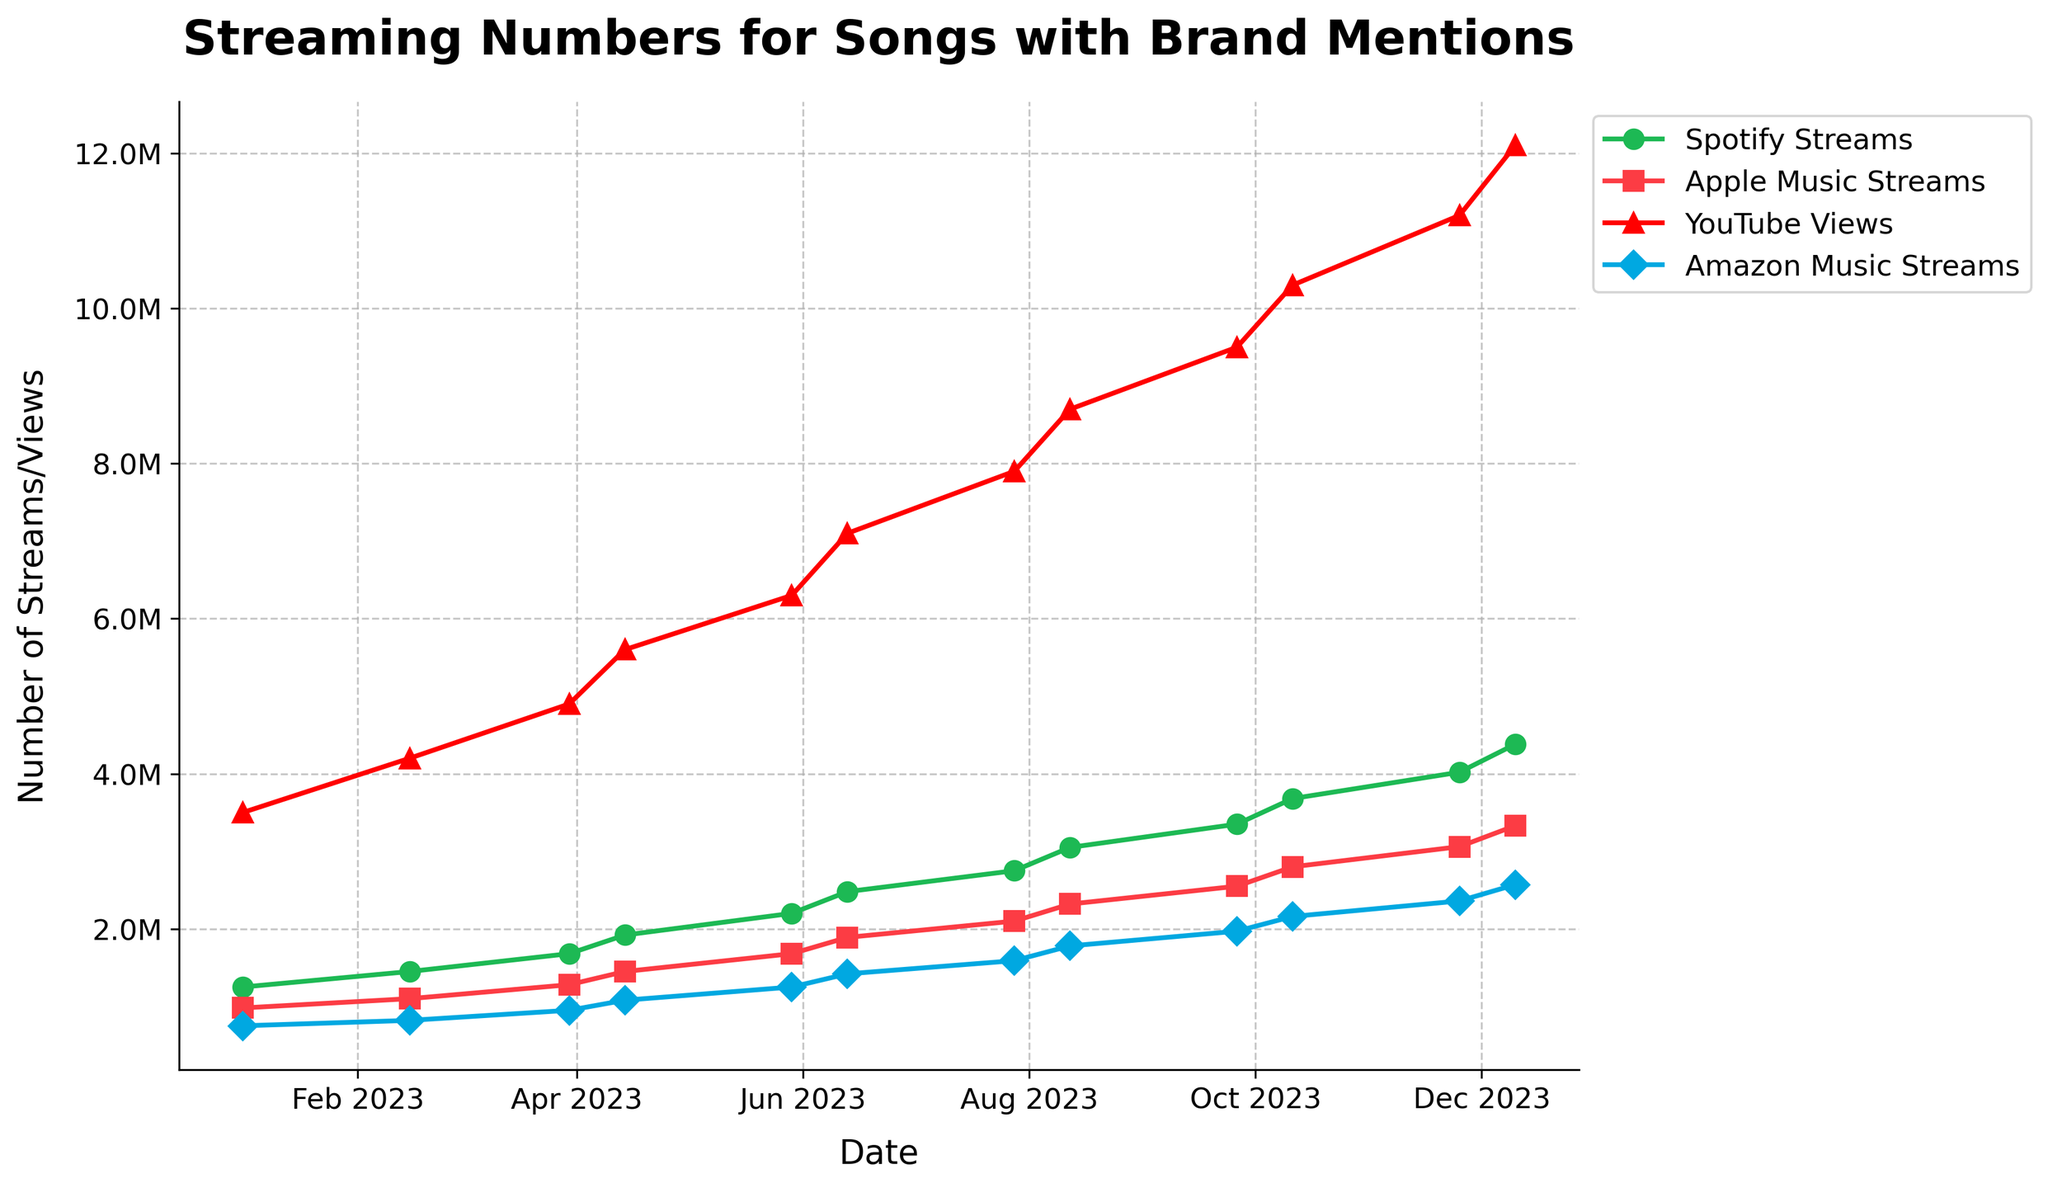How do the number of YouTube Views compare to Spotify Streams on December 10, 2023? YouTube Views are 12.1 million on December 10, 2023, while Spotify Streams are 4.38 million on the same date. By comparing these figures, YouTube Views are substantially higher than Spotify Streams.
Answer: YouTube Views are higher What is the difference between Apple Music Streams on June 13, 2023, and September 26, 2023? Apple Music Streams on June 13, 2023, were 1.89 million, and on September 26, 2023, they were 2.55 million. The difference is calculated as 2.55 million - 1.89 million = 0.66 million.
Answer: 0.66 million Which platform shows the highest growth from January 1, 2023, to December 10, 2023? To determine the highest growth, we calculate the increase for each platform from January 1, 2023, to December 10, 2023:
- Spotify: 4.38 million - 1.25 million = 3.13 million
- Apple Music: 3.33 million - 0.98 million = 2.35 million
- YouTube: 12.1 million - 3.5 million = 8.6 million
- Amazon Music: 2.57 million - 0.75 million = 1.82 million
YouTube shows the highest growth of 8.6 million.
Answer: YouTube Which platform had the least number of streams/views on March 30, 2023? On March 30, 2023, the data is as follows:
- Spotify Streams: 1.68 million 
- Apple Music Streams: 1.28 million 
- YouTube Views: 4.9 million 
- Amazon Music Streams: 0.95 million
Amazon Music Streams had the least number of streams/views with 0.95 million.
Answer: Amazon Music What was the average number of Spotify Streams across all the given dates? First, sum up all the Spotify Streams and then divide by the number of data points:
(1.25 + 1.45 + 1.68 + 1.92 + 2.20 + 2.48 + 2.75 + 3.05 + 3.35 + 3.68 + 4.02 + 4.38) million / 12 = 2.72 million.
Answer: 2.72 million On what date did Amazon Music Streams first exceed 1 million? The data shows that on May 29, 2023, Amazon Music Streams reached 1.25 million, which is the first time it exceeded 1 million.
Answer: May 29, 2023 How much did the number of YouTube Views increase from June 13, 2023, to December 10, 2023? YouTube Views on June 13, 2023, were 7.1 million, and on December 10, 2023, they were 12.1 million. To find the increase, subtract the initial value from the final value: 12.1 million - 7.1 million = 5 million.
Answer: 5 million What are the total streams/views for all platforms combined on November 25, 2023? To find the total, we sum the streaming numbers for all platforms on November 25, 2023: 
4.02 million (Spotify) + 3.06 million (Apple Music) + 11.2 million (YouTube) + 2.36 million (Amazon Music) = 20.64 million.
Answer: 20.64 million 